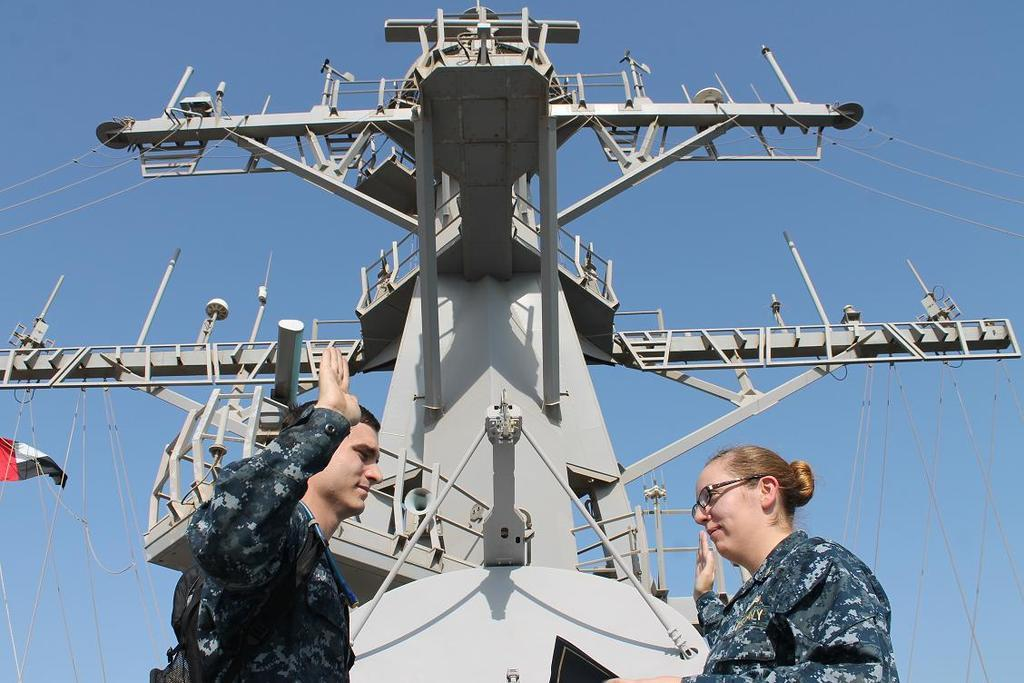How many people are present in the image? There is a man and a woman present in the image. What is the woman wearing in the image? The woman is wearing spectacles in the image. What can be seen in the background of the image? There is a tower and a flag in the image. What is the color of the sky in the image? The sky is blue in the image. What type of chair is the man sitting on in the image? There is no chair present in the image, and the man is not sitting. What channel is the woman watching on the television in the image? There is no television present in the image, so it is not possible to determine what channel the woman might be watching. 